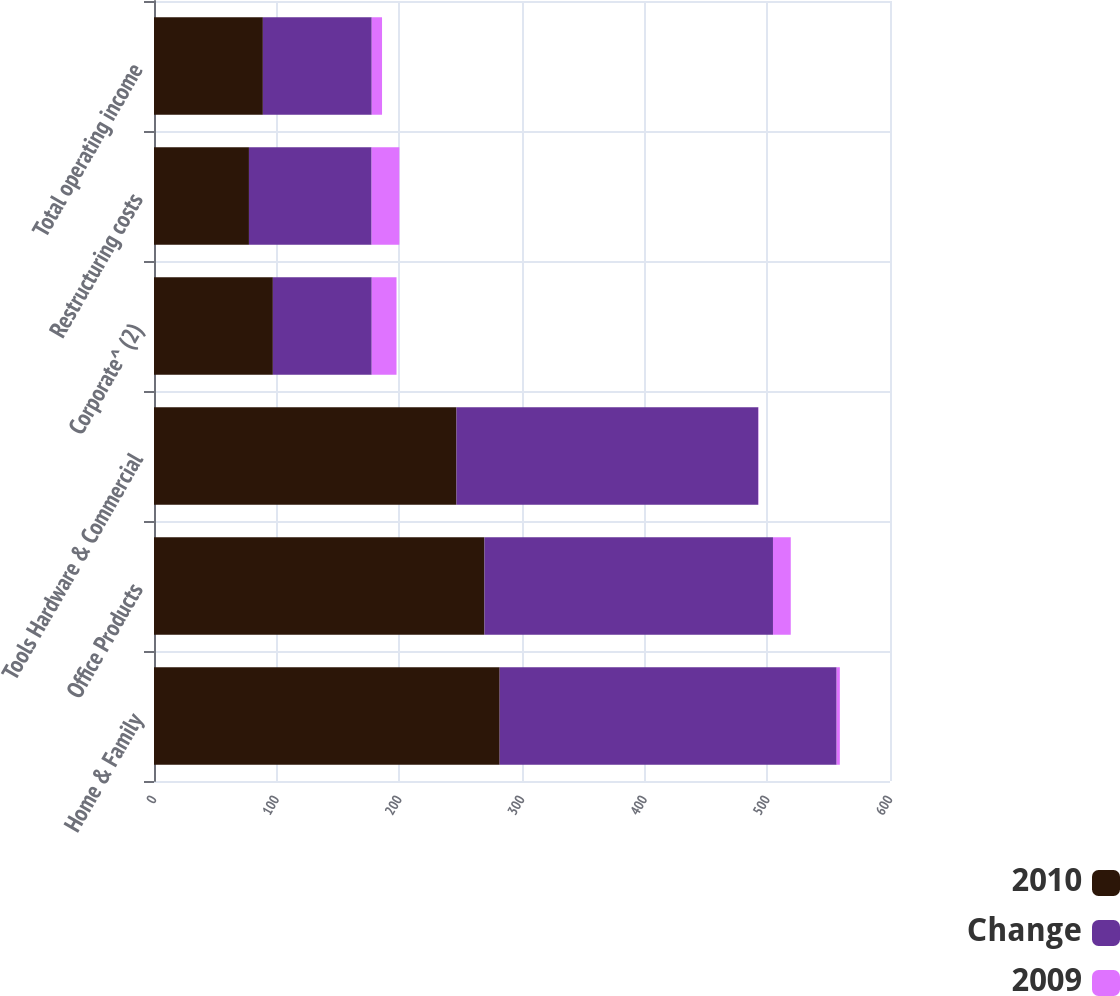Convert chart to OTSL. <chart><loc_0><loc_0><loc_500><loc_500><stacked_bar_chart><ecel><fcel>Home & Family<fcel>Office Products<fcel>Tools Hardware & Commercial<fcel>Corporate^ (2)<fcel>Restructuring costs<fcel>Total operating income<nl><fcel>2010<fcel>281.8<fcel>269.4<fcel>246.6<fcel>96.9<fcel>77.4<fcel>88.75<nl><fcel>Change<fcel>274.7<fcel>235.2<fcel>246<fcel>80.6<fcel>100<fcel>88.75<nl><fcel>2009<fcel>2.6<fcel>14.5<fcel>0.2<fcel>20.2<fcel>22.6<fcel>8.4<nl></chart> 